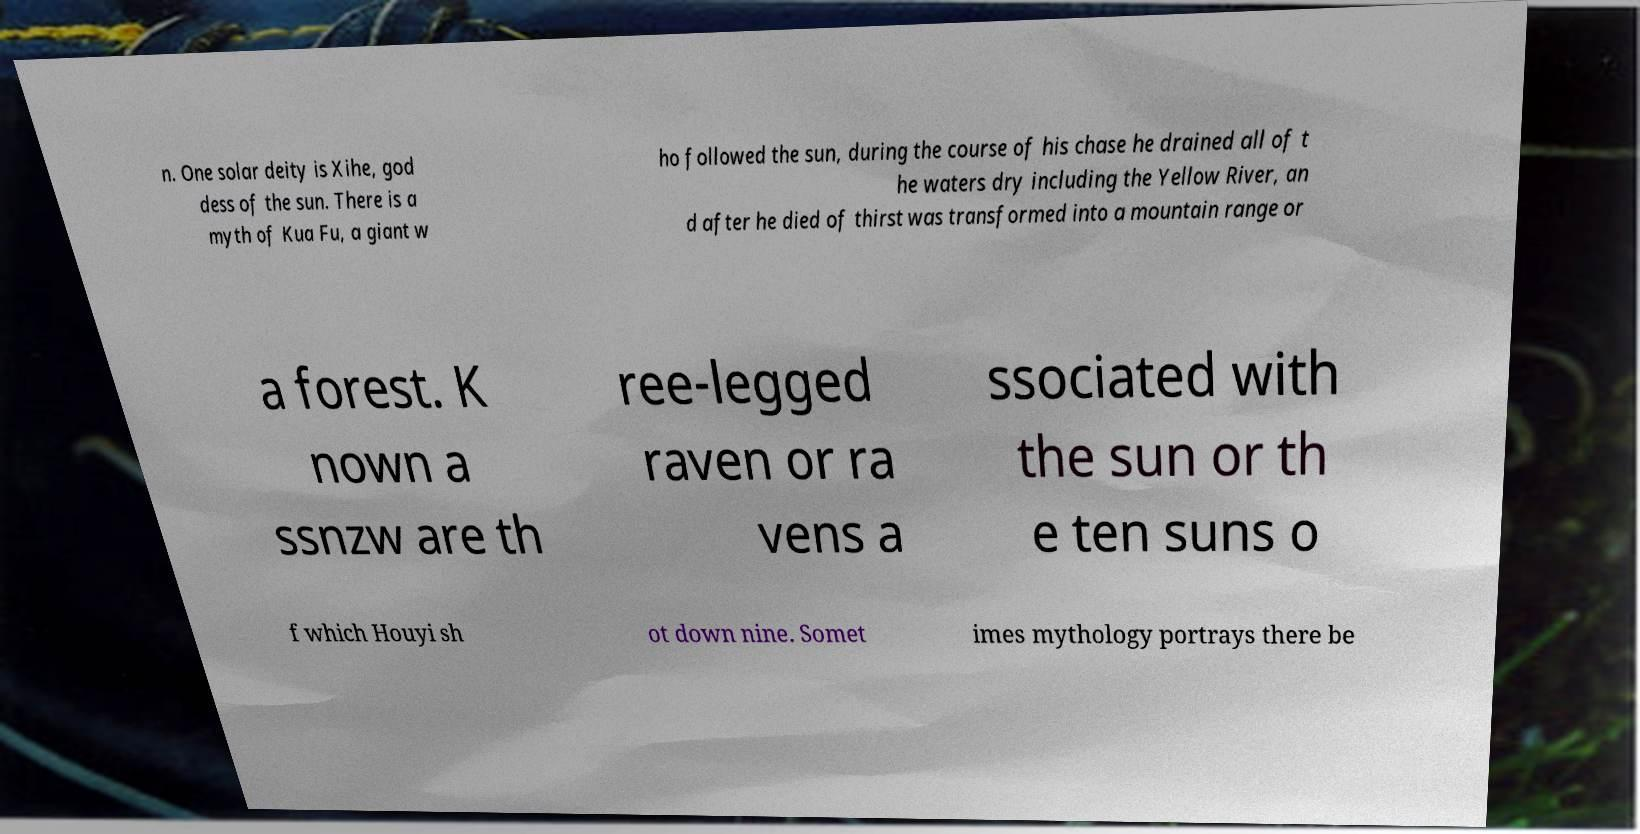Please identify and transcribe the text found in this image. n. One solar deity is Xihe, god dess of the sun. There is a myth of Kua Fu, a giant w ho followed the sun, during the course of his chase he drained all of t he waters dry including the Yellow River, an d after he died of thirst was transformed into a mountain range or a forest. K nown a ssnzw are th ree-legged raven or ra vens a ssociated with the sun or th e ten suns o f which Houyi sh ot down nine. Somet imes mythology portrays there be 